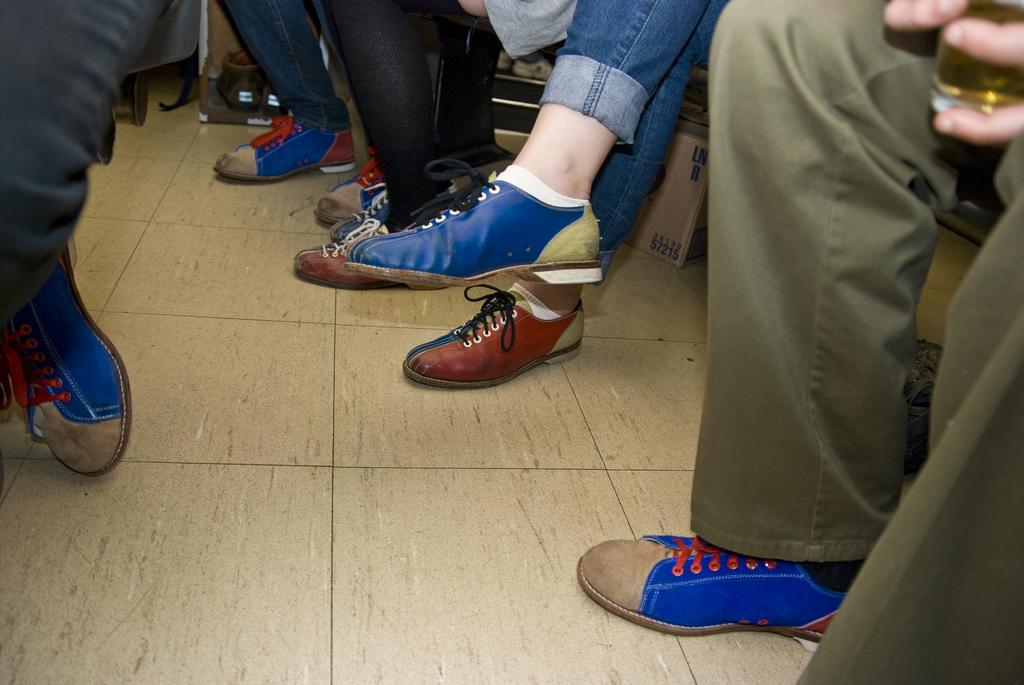What can be seen in the image that indicates the presence of people? There are legs of people visible in the image. What type of footwear are the people wearing? The people are wearing footwear. What object can be seen in the image that is not related to the people? There is a box in the image. Can you describe any other objects present in the image? There are other objects in the image, but their specific details are not mentioned in the provided facts. What type of advertisement can be seen hanging from the ceiling in the image? There is no advertisement present in the image; it only features legs of people, footwear, a box, and other unspecified objects. Can you tell me how many icicles are hanging from the box in the image? There are no icicles present in the image. 